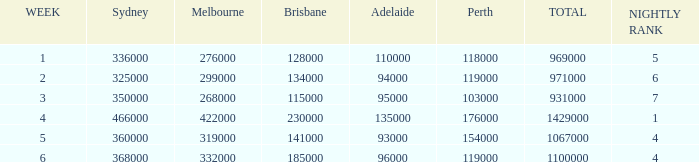What was the rating in Brisbane the week it was 276000 in Melbourne?  128000.0. 